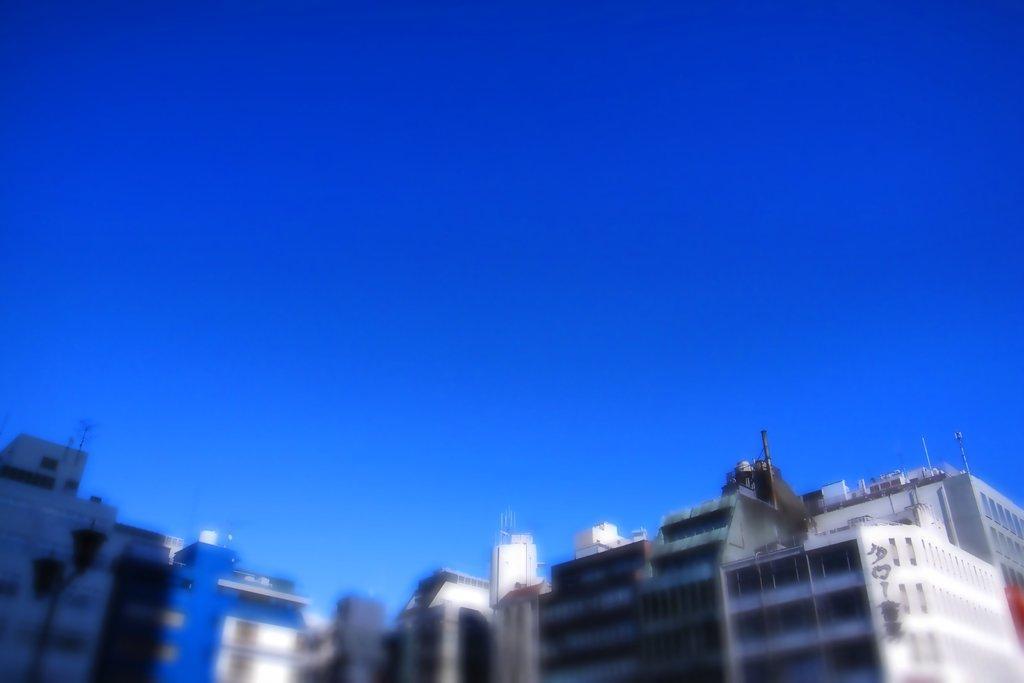In one or two sentences, can you explain what this image depicts? This image consists of many buildings. At the top, there is the sky in blue color. And the image is blurred. 